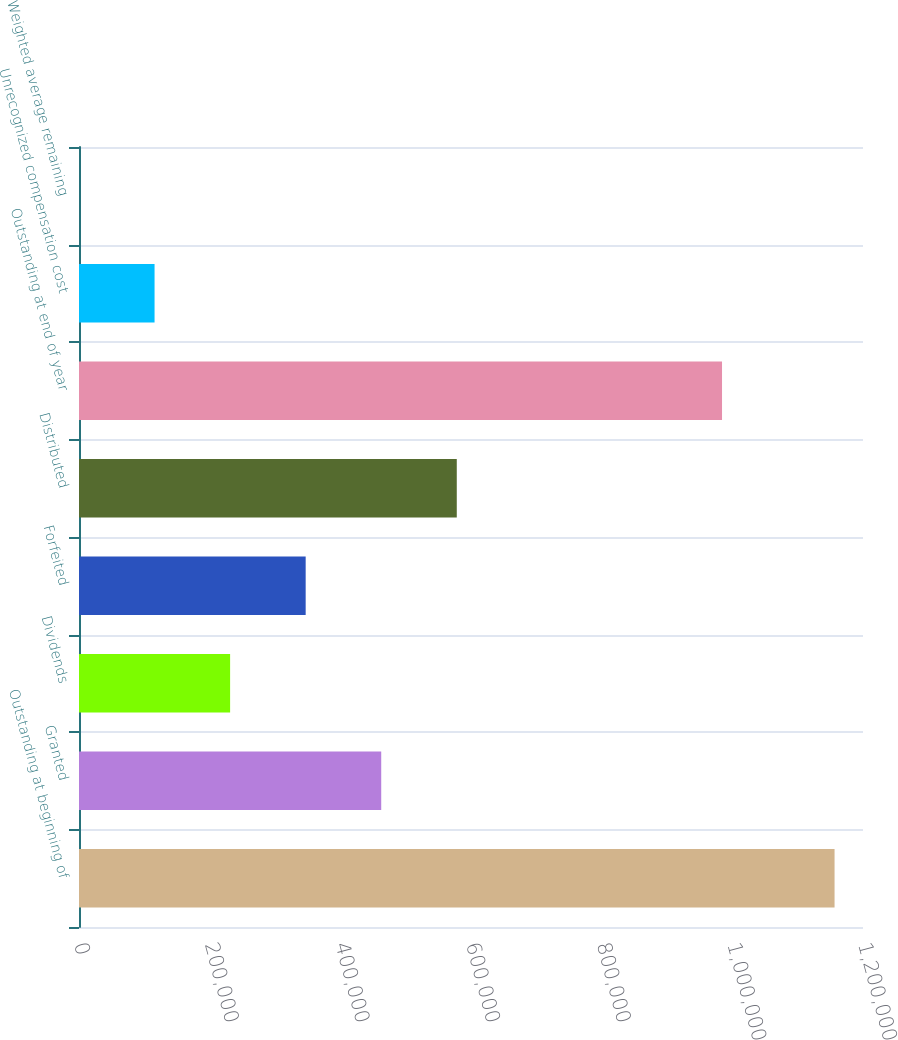Convert chart to OTSL. <chart><loc_0><loc_0><loc_500><loc_500><bar_chart><fcel>Outstanding at beginning of<fcel>Granted<fcel>Dividends<fcel>Forfeited<fcel>Distributed<fcel>Outstanding at end of year<fcel>Unrecognized compensation cost<fcel>Weighted average remaining<nl><fcel>1.15646e+06<fcel>462587<fcel>231295<fcel>346941<fcel>578233<fcel>984235<fcel>115649<fcel>3.1<nl></chart> 